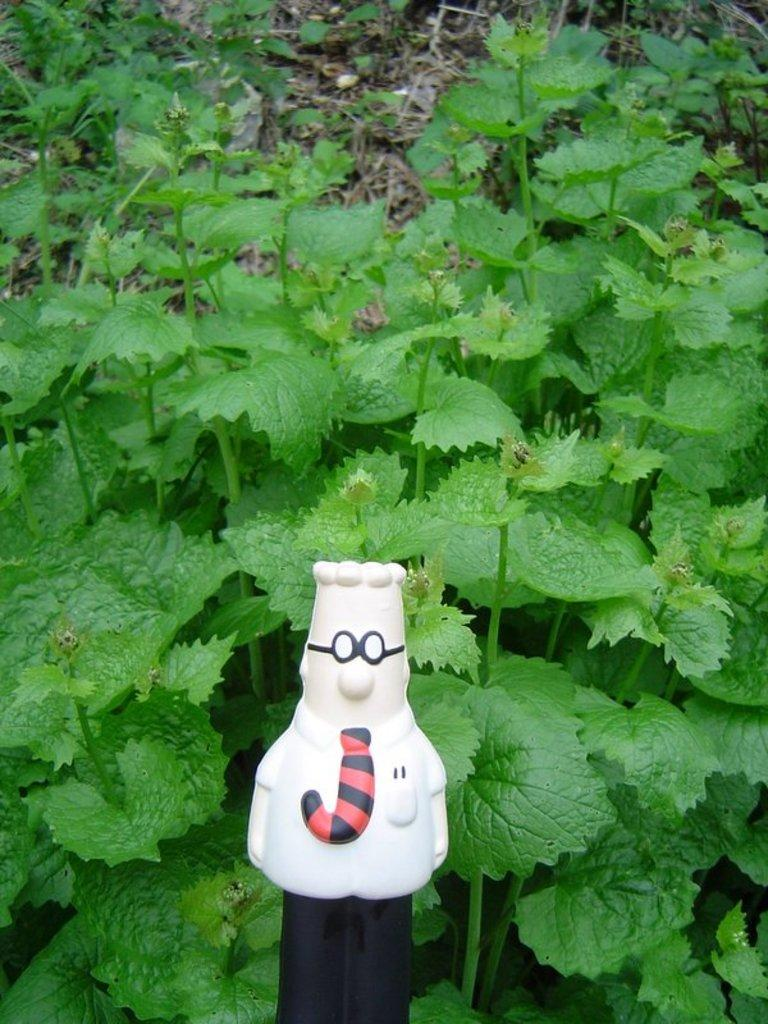What object in the image is designed for play or amusement? There is a toy in the image. What type of living organisms can be seen in the image? Plants are visible in the image. How are the plants positioned in relation to the toy? The plants are behind the toy. How many visitors can be seen interacting with the toy in the image? There are no visitors present in the image; it only features a toy and plants. What type of kiss can be seen on the toy in the image? There is no kiss present on the toy in the image. 